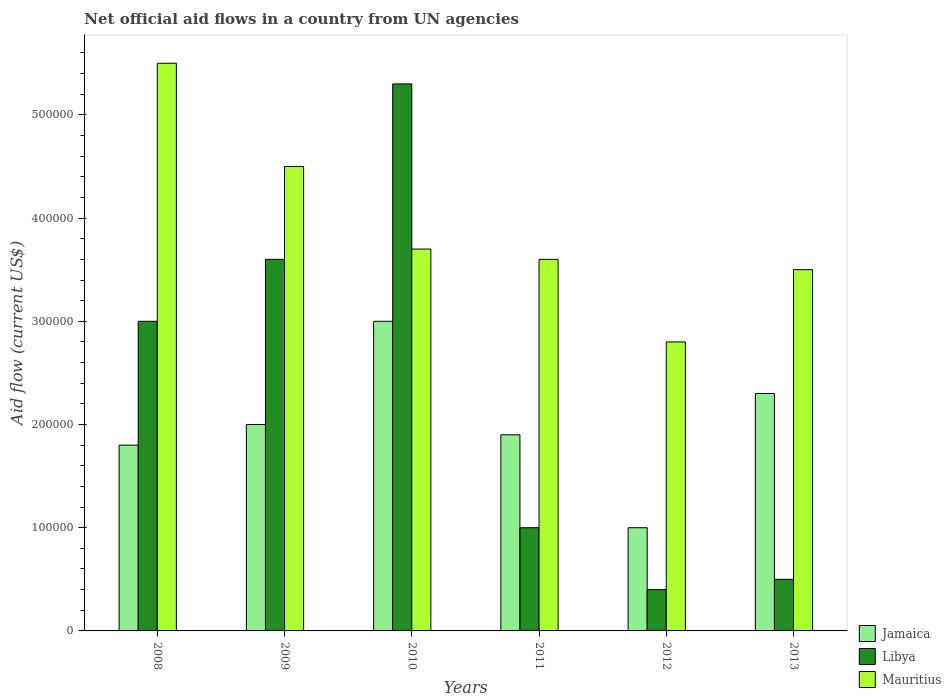How many groups of bars are there?
Your answer should be compact. 6. Are the number of bars on each tick of the X-axis equal?
Your response must be concise. Yes. How many bars are there on the 2nd tick from the right?
Make the answer very short. 3. What is the label of the 4th group of bars from the left?
Your answer should be very brief. 2011. What is the net official aid flow in Mauritius in 2013?
Give a very brief answer. 3.50e+05. Across all years, what is the maximum net official aid flow in Jamaica?
Your answer should be compact. 3.00e+05. Across all years, what is the minimum net official aid flow in Jamaica?
Provide a short and direct response. 1.00e+05. In which year was the net official aid flow in Jamaica maximum?
Ensure brevity in your answer.  2010. In which year was the net official aid flow in Mauritius minimum?
Your answer should be very brief. 2012. What is the total net official aid flow in Jamaica in the graph?
Provide a short and direct response. 1.20e+06. What is the difference between the net official aid flow in Mauritius in 2010 and that in 2012?
Ensure brevity in your answer.  9.00e+04. What is the difference between the net official aid flow in Mauritius in 2012 and the net official aid flow in Jamaica in 2013?
Your response must be concise. 5.00e+04. What is the average net official aid flow in Mauritius per year?
Keep it short and to the point. 3.93e+05. In the year 2008, what is the difference between the net official aid flow in Jamaica and net official aid flow in Mauritius?
Your response must be concise. -3.70e+05. What is the ratio of the net official aid flow in Mauritius in 2011 to that in 2012?
Offer a terse response. 1.29. Is the net official aid flow in Libya in 2009 less than that in 2011?
Your response must be concise. No. Is the difference between the net official aid flow in Jamaica in 2009 and 2011 greater than the difference between the net official aid flow in Mauritius in 2009 and 2011?
Provide a succinct answer. No. What is the difference between the highest and the second highest net official aid flow in Mauritius?
Offer a terse response. 1.00e+05. What is the difference between the highest and the lowest net official aid flow in Jamaica?
Ensure brevity in your answer.  2.00e+05. In how many years, is the net official aid flow in Jamaica greater than the average net official aid flow in Jamaica taken over all years?
Provide a succinct answer. 2. Is the sum of the net official aid flow in Mauritius in 2009 and 2011 greater than the maximum net official aid flow in Jamaica across all years?
Make the answer very short. Yes. What does the 2nd bar from the left in 2012 represents?
Ensure brevity in your answer.  Libya. What does the 3rd bar from the right in 2010 represents?
Ensure brevity in your answer.  Jamaica. Is it the case that in every year, the sum of the net official aid flow in Libya and net official aid flow in Mauritius is greater than the net official aid flow in Jamaica?
Keep it short and to the point. Yes. Does the graph contain any zero values?
Your answer should be compact. No. How are the legend labels stacked?
Your answer should be compact. Vertical. What is the title of the graph?
Your answer should be compact. Net official aid flows in a country from UN agencies. What is the label or title of the Y-axis?
Your answer should be very brief. Aid flow (current US$). What is the Aid flow (current US$) in Jamaica in 2008?
Your response must be concise. 1.80e+05. What is the Aid flow (current US$) of Libya in 2008?
Keep it short and to the point. 3.00e+05. What is the Aid flow (current US$) in Mauritius in 2008?
Your response must be concise. 5.50e+05. What is the Aid flow (current US$) in Mauritius in 2009?
Provide a succinct answer. 4.50e+05. What is the Aid flow (current US$) of Libya in 2010?
Ensure brevity in your answer.  5.30e+05. What is the Aid flow (current US$) in Mauritius in 2011?
Offer a terse response. 3.60e+05. What is the Aid flow (current US$) of Libya in 2012?
Provide a succinct answer. 4.00e+04. What is the Aid flow (current US$) in Mauritius in 2013?
Provide a short and direct response. 3.50e+05. Across all years, what is the maximum Aid flow (current US$) in Libya?
Your response must be concise. 5.30e+05. Across all years, what is the minimum Aid flow (current US$) of Jamaica?
Your answer should be very brief. 1.00e+05. What is the total Aid flow (current US$) of Jamaica in the graph?
Keep it short and to the point. 1.20e+06. What is the total Aid flow (current US$) in Libya in the graph?
Offer a very short reply. 1.38e+06. What is the total Aid flow (current US$) in Mauritius in the graph?
Give a very brief answer. 2.36e+06. What is the difference between the Aid flow (current US$) of Jamaica in 2008 and that in 2009?
Your answer should be compact. -2.00e+04. What is the difference between the Aid flow (current US$) in Libya in 2008 and that in 2009?
Your answer should be very brief. -6.00e+04. What is the difference between the Aid flow (current US$) in Jamaica in 2008 and that in 2010?
Keep it short and to the point. -1.20e+05. What is the difference between the Aid flow (current US$) in Jamaica in 2008 and that in 2011?
Your answer should be very brief. -10000. What is the difference between the Aid flow (current US$) in Jamaica in 2008 and that in 2012?
Provide a short and direct response. 8.00e+04. What is the difference between the Aid flow (current US$) of Libya in 2008 and that in 2013?
Provide a short and direct response. 2.50e+05. What is the difference between the Aid flow (current US$) in Mauritius in 2008 and that in 2013?
Provide a succinct answer. 2.00e+05. What is the difference between the Aid flow (current US$) of Jamaica in 2009 and that in 2010?
Your answer should be compact. -1.00e+05. What is the difference between the Aid flow (current US$) of Libya in 2009 and that in 2011?
Offer a terse response. 2.60e+05. What is the difference between the Aid flow (current US$) in Mauritius in 2009 and that in 2011?
Offer a terse response. 9.00e+04. What is the difference between the Aid flow (current US$) of Jamaica in 2009 and that in 2012?
Make the answer very short. 1.00e+05. What is the difference between the Aid flow (current US$) of Mauritius in 2009 and that in 2012?
Your response must be concise. 1.70e+05. What is the difference between the Aid flow (current US$) in Jamaica in 2009 and that in 2013?
Ensure brevity in your answer.  -3.00e+04. What is the difference between the Aid flow (current US$) in Libya in 2009 and that in 2013?
Your response must be concise. 3.10e+05. What is the difference between the Aid flow (current US$) in Mauritius in 2009 and that in 2013?
Make the answer very short. 1.00e+05. What is the difference between the Aid flow (current US$) of Mauritius in 2010 and that in 2011?
Provide a short and direct response. 10000. What is the difference between the Aid flow (current US$) in Jamaica in 2010 and that in 2012?
Your answer should be compact. 2.00e+05. What is the difference between the Aid flow (current US$) in Libya in 2010 and that in 2012?
Your answer should be very brief. 4.90e+05. What is the difference between the Aid flow (current US$) in Mauritius in 2010 and that in 2012?
Provide a succinct answer. 9.00e+04. What is the difference between the Aid flow (current US$) of Libya in 2011 and that in 2012?
Offer a very short reply. 6.00e+04. What is the difference between the Aid flow (current US$) of Mauritius in 2011 and that in 2012?
Provide a short and direct response. 8.00e+04. What is the difference between the Aid flow (current US$) in Jamaica in 2011 and that in 2013?
Your response must be concise. -4.00e+04. What is the difference between the Aid flow (current US$) of Libya in 2011 and that in 2013?
Your answer should be compact. 5.00e+04. What is the difference between the Aid flow (current US$) in Mauritius in 2011 and that in 2013?
Make the answer very short. 10000. What is the difference between the Aid flow (current US$) in Jamaica in 2008 and the Aid flow (current US$) in Mauritius in 2009?
Keep it short and to the point. -2.70e+05. What is the difference between the Aid flow (current US$) in Jamaica in 2008 and the Aid flow (current US$) in Libya in 2010?
Offer a terse response. -3.50e+05. What is the difference between the Aid flow (current US$) in Jamaica in 2008 and the Aid flow (current US$) in Libya in 2011?
Keep it short and to the point. 8.00e+04. What is the difference between the Aid flow (current US$) in Jamaica in 2008 and the Aid flow (current US$) in Mauritius in 2011?
Give a very brief answer. -1.80e+05. What is the difference between the Aid flow (current US$) of Libya in 2008 and the Aid flow (current US$) of Mauritius in 2011?
Make the answer very short. -6.00e+04. What is the difference between the Aid flow (current US$) in Jamaica in 2008 and the Aid flow (current US$) in Libya in 2012?
Offer a very short reply. 1.40e+05. What is the difference between the Aid flow (current US$) of Jamaica in 2008 and the Aid flow (current US$) of Mauritius in 2012?
Keep it short and to the point. -1.00e+05. What is the difference between the Aid flow (current US$) in Libya in 2008 and the Aid flow (current US$) in Mauritius in 2012?
Your answer should be very brief. 2.00e+04. What is the difference between the Aid flow (current US$) of Jamaica in 2008 and the Aid flow (current US$) of Mauritius in 2013?
Your response must be concise. -1.70e+05. What is the difference between the Aid flow (current US$) of Jamaica in 2009 and the Aid flow (current US$) of Libya in 2010?
Make the answer very short. -3.30e+05. What is the difference between the Aid flow (current US$) of Jamaica in 2009 and the Aid flow (current US$) of Libya in 2011?
Provide a short and direct response. 1.00e+05. What is the difference between the Aid flow (current US$) of Jamaica in 2009 and the Aid flow (current US$) of Libya in 2012?
Offer a very short reply. 1.60e+05. What is the difference between the Aid flow (current US$) of Jamaica in 2009 and the Aid flow (current US$) of Mauritius in 2012?
Give a very brief answer. -8.00e+04. What is the difference between the Aid flow (current US$) in Libya in 2009 and the Aid flow (current US$) in Mauritius in 2012?
Ensure brevity in your answer.  8.00e+04. What is the difference between the Aid flow (current US$) of Jamaica in 2009 and the Aid flow (current US$) of Libya in 2013?
Keep it short and to the point. 1.50e+05. What is the difference between the Aid flow (current US$) in Jamaica in 2010 and the Aid flow (current US$) in Libya in 2011?
Offer a terse response. 2.00e+05. What is the difference between the Aid flow (current US$) in Libya in 2010 and the Aid flow (current US$) in Mauritius in 2011?
Your answer should be very brief. 1.70e+05. What is the difference between the Aid flow (current US$) in Jamaica in 2010 and the Aid flow (current US$) in Mauritius in 2012?
Offer a terse response. 2.00e+04. What is the difference between the Aid flow (current US$) in Libya in 2010 and the Aid flow (current US$) in Mauritius in 2012?
Keep it short and to the point. 2.50e+05. What is the difference between the Aid flow (current US$) in Jamaica in 2011 and the Aid flow (current US$) in Mauritius in 2012?
Your answer should be compact. -9.00e+04. What is the difference between the Aid flow (current US$) of Libya in 2011 and the Aid flow (current US$) of Mauritius in 2012?
Offer a terse response. -1.80e+05. What is the difference between the Aid flow (current US$) in Jamaica in 2011 and the Aid flow (current US$) in Mauritius in 2013?
Make the answer very short. -1.60e+05. What is the difference between the Aid flow (current US$) of Libya in 2012 and the Aid flow (current US$) of Mauritius in 2013?
Make the answer very short. -3.10e+05. What is the average Aid flow (current US$) of Libya per year?
Ensure brevity in your answer.  2.30e+05. What is the average Aid flow (current US$) in Mauritius per year?
Your answer should be very brief. 3.93e+05. In the year 2008, what is the difference between the Aid flow (current US$) of Jamaica and Aid flow (current US$) of Libya?
Make the answer very short. -1.20e+05. In the year 2008, what is the difference between the Aid flow (current US$) in Jamaica and Aid flow (current US$) in Mauritius?
Offer a terse response. -3.70e+05. In the year 2009, what is the difference between the Aid flow (current US$) in Jamaica and Aid flow (current US$) in Mauritius?
Provide a succinct answer. -2.50e+05. In the year 2009, what is the difference between the Aid flow (current US$) of Libya and Aid flow (current US$) of Mauritius?
Provide a succinct answer. -9.00e+04. In the year 2010, what is the difference between the Aid flow (current US$) in Jamaica and Aid flow (current US$) in Libya?
Provide a succinct answer. -2.30e+05. In the year 2010, what is the difference between the Aid flow (current US$) in Jamaica and Aid flow (current US$) in Mauritius?
Your response must be concise. -7.00e+04. In the year 2012, what is the difference between the Aid flow (current US$) of Jamaica and Aid flow (current US$) of Libya?
Offer a very short reply. 6.00e+04. In the year 2012, what is the difference between the Aid flow (current US$) of Libya and Aid flow (current US$) of Mauritius?
Provide a short and direct response. -2.40e+05. In the year 2013, what is the difference between the Aid flow (current US$) of Jamaica and Aid flow (current US$) of Mauritius?
Give a very brief answer. -1.20e+05. What is the ratio of the Aid flow (current US$) of Libya in 2008 to that in 2009?
Offer a very short reply. 0.83. What is the ratio of the Aid flow (current US$) of Mauritius in 2008 to that in 2009?
Ensure brevity in your answer.  1.22. What is the ratio of the Aid flow (current US$) in Libya in 2008 to that in 2010?
Your answer should be compact. 0.57. What is the ratio of the Aid flow (current US$) of Mauritius in 2008 to that in 2010?
Your answer should be very brief. 1.49. What is the ratio of the Aid flow (current US$) of Libya in 2008 to that in 2011?
Ensure brevity in your answer.  3. What is the ratio of the Aid flow (current US$) of Mauritius in 2008 to that in 2011?
Ensure brevity in your answer.  1.53. What is the ratio of the Aid flow (current US$) of Jamaica in 2008 to that in 2012?
Ensure brevity in your answer.  1.8. What is the ratio of the Aid flow (current US$) of Mauritius in 2008 to that in 2012?
Provide a succinct answer. 1.96. What is the ratio of the Aid flow (current US$) of Jamaica in 2008 to that in 2013?
Provide a short and direct response. 0.78. What is the ratio of the Aid flow (current US$) in Libya in 2008 to that in 2013?
Provide a succinct answer. 6. What is the ratio of the Aid flow (current US$) in Mauritius in 2008 to that in 2013?
Keep it short and to the point. 1.57. What is the ratio of the Aid flow (current US$) of Libya in 2009 to that in 2010?
Offer a very short reply. 0.68. What is the ratio of the Aid flow (current US$) of Mauritius in 2009 to that in 2010?
Give a very brief answer. 1.22. What is the ratio of the Aid flow (current US$) in Jamaica in 2009 to that in 2011?
Keep it short and to the point. 1.05. What is the ratio of the Aid flow (current US$) of Libya in 2009 to that in 2011?
Your response must be concise. 3.6. What is the ratio of the Aid flow (current US$) in Mauritius in 2009 to that in 2011?
Provide a succinct answer. 1.25. What is the ratio of the Aid flow (current US$) in Jamaica in 2009 to that in 2012?
Ensure brevity in your answer.  2. What is the ratio of the Aid flow (current US$) of Mauritius in 2009 to that in 2012?
Make the answer very short. 1.61. What is the ratio of the Aid flow (current US$) in Jamaica in 2009 to that in 2013?
Make the answer very short. 0.87. What is the ratio of the Aid flow (current US$) in Jamaica in 2010 to that in 2011?
Offer a very short reply. 1.58. What is the ratio of the Aid flow (current US$) in Mauritius in 2010 to that in 2011?
Ensure brevity in your answer.  1.03. What is the ratio of the Aid flow (current US$) in Jamaica in 2010 to that in 2012?
Your answer should be very brief. 3. What is the ratio of the Aid flow (current US$) of Libya in 2010 to that in 2012?
Your answer should be very brief. 13.25. What is the ratio of the Aid flow (current US$) of Mauritius in 2010 to that in 2012?
Your response must be concise. 1.32. What is the ratio of the Aid flow (current US$) of Jamaica in 2010 to that in 2013?
Ensure brevity in your answer.  1.3. What is the ratio of the Aid flow (current US$) in Libya in 2010 to that in 2013?
Offer a very short reply. 10.6. What is the ratio of the Aid flow (current US$) in Mauritius in 2010 to that in 2013?
Provide a short and direct response. 1.06. What is the ratio of the Aid flow (current US$) of Jamaica in 2011 to that in 2012?
Your answer should be compact. 1.9. What is the ratio of the Aid flow (current US$) in Libya in 2011 to that in 2012?
Your response must be concise. 2.5. What is the ratio of the Aid flow (current US$) in Mauritius in 2011 to that in 2012?
Offer a terse response. 1.29. What is the ratio of the Aid flow (current US$) in Jamaica in 2011 to that in 2013?
Your response must be concise. 0.83. What is the ratio of the Aid flow (current US$) of Libya in 2011 to that in 2013?
Offer a terse response. 2. What is the ratio of the Aid flow (current US$) in Mauritius in 2011 to that in 2013?
Your answer should be very brief. 1.03. What is the ratio of the Aid flow (current US$) in Jamaica in 2012 to that in 2013?
Give a very brief answer. 0.43. What is the difference between the highest and the second highest Aid flow (current US$) of Jamaica?
Ensure brevity in your answer.  7.00e+04. What is the difference between the highest and the second highest Aid flow (current US$) in Mauritius?
Offer a very short reply. 1.00e+05. 